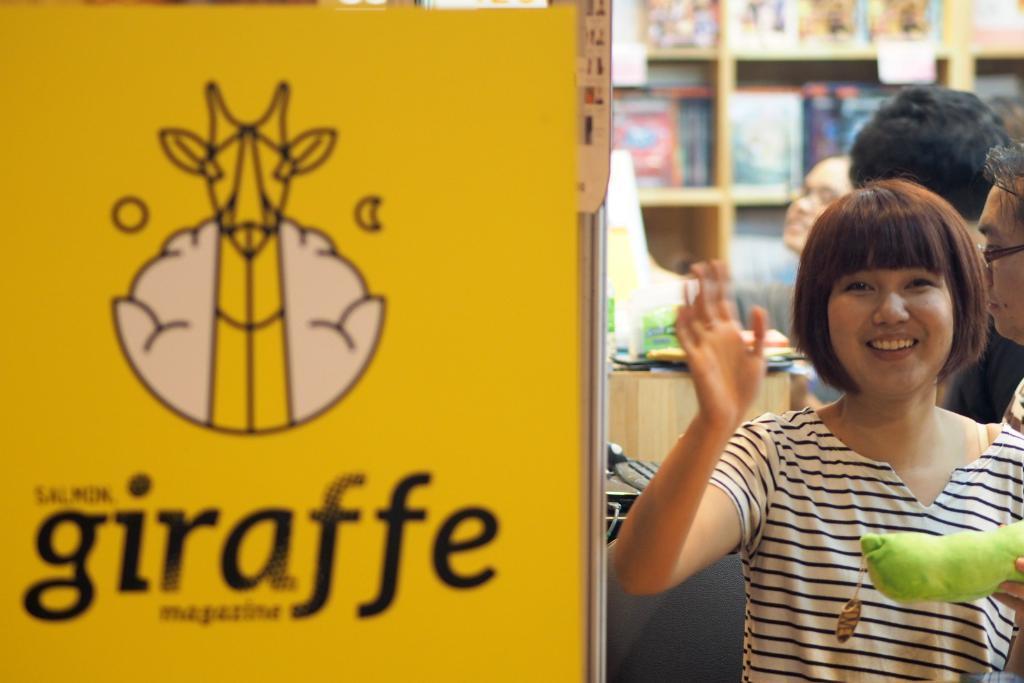In one or two sentences, can you explain what this image depicts? On the left of this picture we can see the text and some pictures on a yellow color object which seems to be the board. On the right we can see the group of persons and we can see a person wearing white color t-shirt, holding some object, smiling and seems to be standing. In the background we can see the wooden cabinets containing many number of objects and we can see there are some objects placed on the top of the wooden object which seems to be the table and we can see many other objects in the background. 